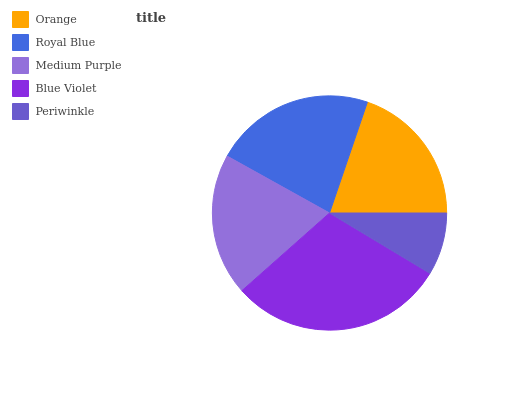Is Periwinkle the minimum?
Answer yes or no. Yes. Is Blue Violet the maximum?
Answer yes or no. Yes. Is Royal Blue the minimum?
Answer yes or no. No. Is Royal Blue the maximum?
Answer yes or no. No. Is Royal Blue greater than Orange?
Answer yes or no. Yes. Is Orange less than Royal Blue?
Answer yes or no. Yes. Is Orange greater than Royal Blue?
Answer yes or no. No. Is Royal Blue less than Orange?
Answer yes or no. No. Is Orange the high median?
Answer yes or no. Yes. Is Orange the low median?
Answer yes or no. Yes. Is Periwinkle the high median?
Answer yes or no. No. Is Medium Purple the low median?
Answer yes or no. No. 